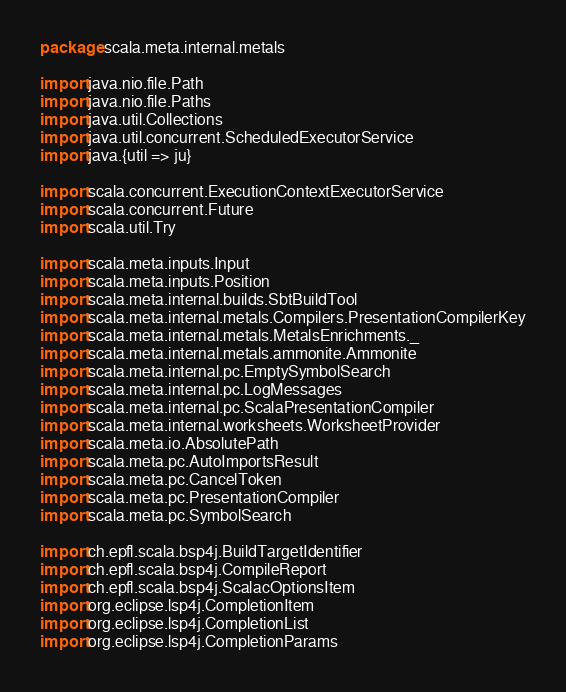<code> <loc_0><loc_0><loc_500><loc_500><_Scala_>package scala.meta.internal.metals

import java.nio.file.Path
import java.nio.file.Paths
import java.util.Collections
import java.util.concurrent.ScheduledExecutorService
import java.{util => ju}

import scala.concurrent.ExecutionContextExecutorService
import scala.concurrent.Future
import scala.util.Try

import scala.meta.inputs.Input
import scala.meta.inputs.Position
import scala.meta.internal.builds.SbtBuildTool
import scala.meta.internal.metals.Compilers.PresentationCompilerKey
import scala.meta.internal.metals.MetalsEnrichments._
import scala.meta.internal.metals.ammonite.Ammonite
import scala.meta.internal.pc.EmptySymbolSearch
import scala.meta.internal.pc.LogMessages
import scala.meta.internal.pc.ScalaPresentationCompiler
import scala.meta.internal.worksheets.WorksheetProvider
import scala.meta.io.AbsolutePath
import scala.meta.pc.AutoImportsResult
import scala.meta.pc.CancelToken
import scala.meta.pc.PresentationCompiler
import scala.meta.pc.SymbolSearch

import ch.epfl.scala.bsp4j.BuildTargetIdentifier
import ch.epfl.scala.bsp4j.CompileReport
import ch.epfl.scala.bsp4j.ScalacOptionsItem
import org.eclipse.lsp4j.CompletionItem
import org.eclipse.lsp4j.CompletionList
import org.eclipse.lsp4j.CompletionParams</code> 